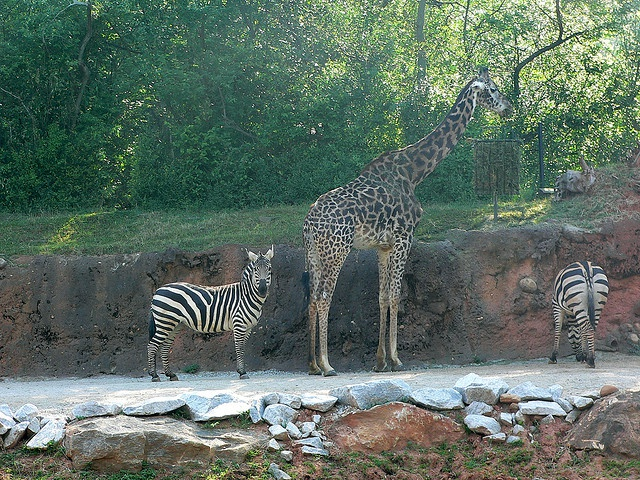Describe the objects in this image and their specific colors. I can see giraffe in teal, gray, darkgray, black, and purple tones, zebra in teal, black, gray, lightgray, and darkgray tones, and zebra in teal, gray, darkgray, black, and lightgray tones in this image. 